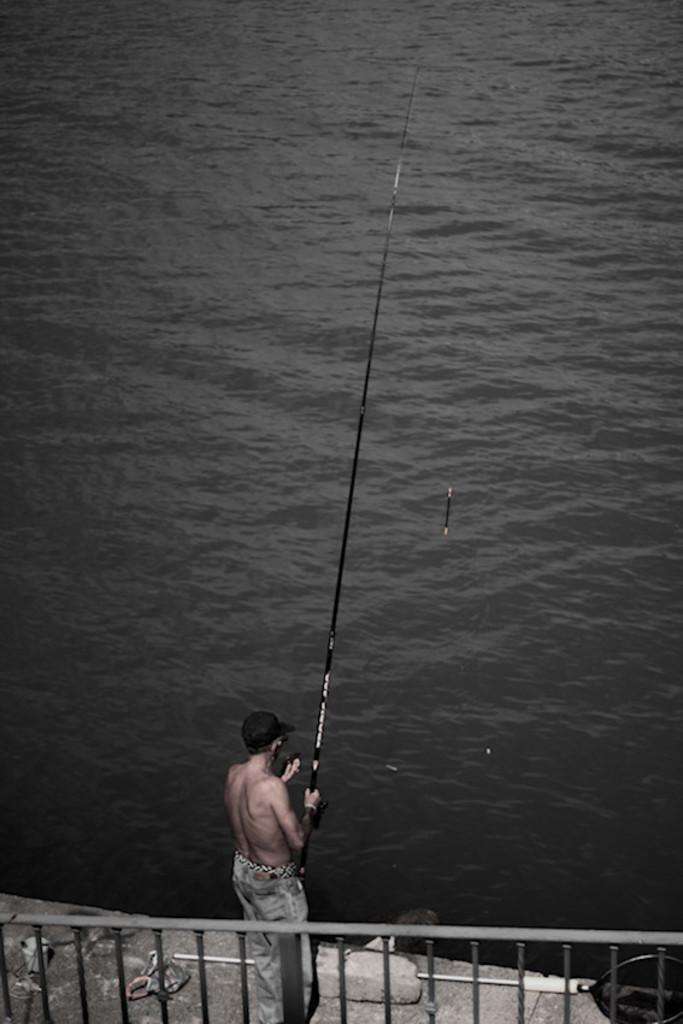Could you give a brief overview of what you see in this image? In the picture we can see a man standing on the path near the ceiling and holding a fishing stick and dropping the string in the water and he is wearing a cap which is black in color. 